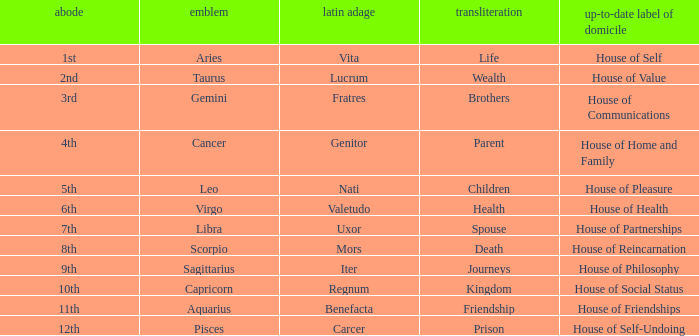Which astrological sign has the Latin motto of Vita? Aries. Parse the table in full. {'header': ['abode', 'emblem', 'latin adage', 'transliteration', 'up-to-date label of domicile'], 'rows': [['1st', 'Aries', 'Vita', 'Life', 'House of Self'], ['2nd', 'Taurus', 'Lucrum', 'Wealth', 'House of Value'], ['3rd', 'Gemini', 'Fratres', 'Brothers', 'House of Communications'], ['4th', 'Cancer', 'Genitor', 'Parent', 'House of Home and Family'], ['5th', 'Leo', 'Nati', 'Children', 'House of Pleasure'], ['6th', 'Virgo', 'Valetudo', 'Health', 'House of Health'], ['7th', 'Libra', 'Uxor', 'Spouse', 'House of Partnerships'], ['8th', 'Scorpio', 'Mors', 'Death', 'House of Reincarnation'], ['9th', 'Sagittarius', 'Iter', 'Journeys', 'House of Philosophy'], ['10th', 'Capricorn', 'Regnum', 'Kingdom', 'House of Social Status'], ['11th', 'Aquarius', 'Benefacta', 'Friendship', 'House of Friendships'], ['12th', 'Pisces', 'Carcer', 'Prison', 'House of Self-Undoing']]} 